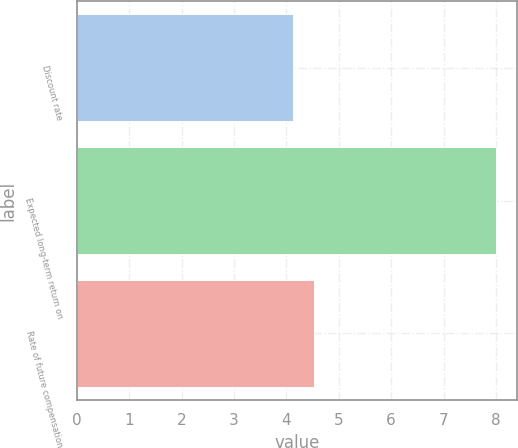<chart> <loc_0><loc_0><loc_500><loc_500><bar_chart><fcel>Discount rate<fcel>Expected long-term return on<fcel>Rate of future compensation<nl><fcel>4.13<fcel>8<fcel>4.52<nl></chart> 